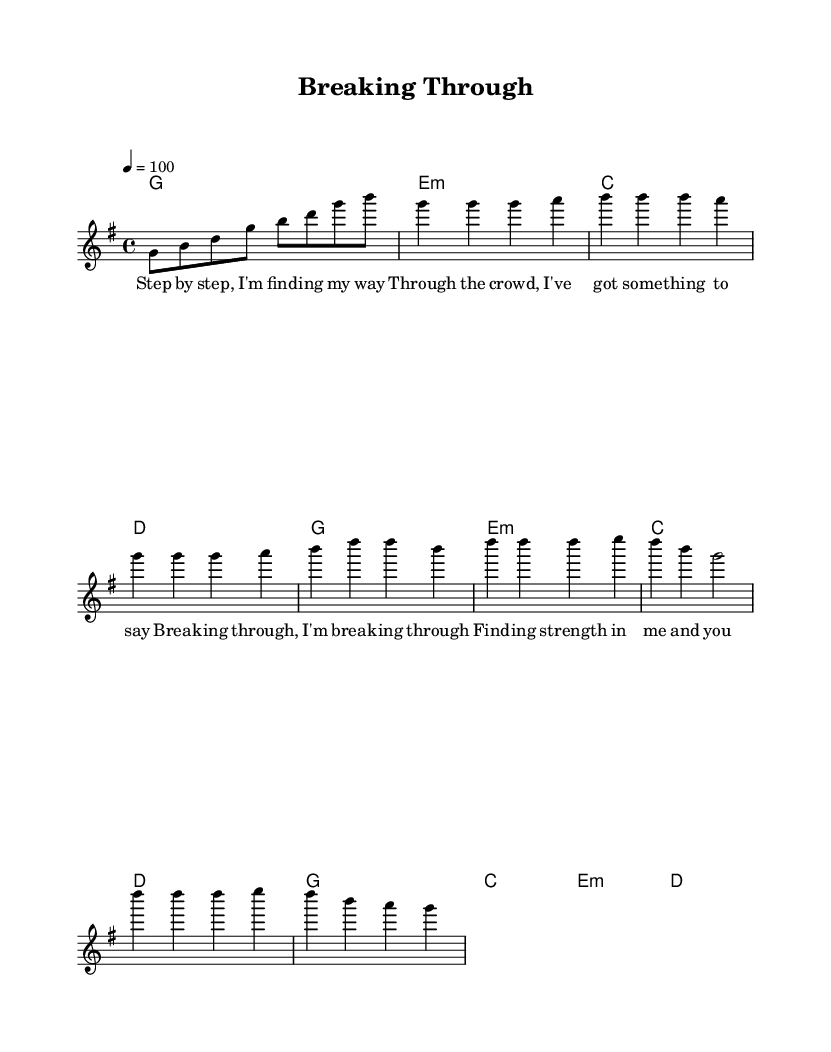What is the key signature of this music? The key signature is G major, which has one sharp (F#).
Answer: G major What is the time signature of this piece? The time signature is 4/4, indicating four beats per measure.
Answer: 4/4 What is the tempo marking given in the music? The tempo marking indicates a speed of 100 beats per minute using the quarter note as the beat.
Answer: 100 How many measures are in the intro section? The intro has four measures, as indicated by the notation.
Answer: 4 Which section includes the lyrics "Step by step, I'm find -- ing my way"? The lyrics are found in the verse section of the music.
Answer: Verse What musical elements contribute to the empowering feel of this anthem? Elements such as the strong chords in the harmony, the uplifting melody, and rhythmic structure promote a sense of support and resilience.
Answer: Chords, melody, rhythm How does the chorus differ from the verse in terms of dynamics? The chorus generally employs a stronger dynamic presence, often characterized by louder and more expressive singing that emphasizes the empowering theme.
Answer: Stronger dynamics 